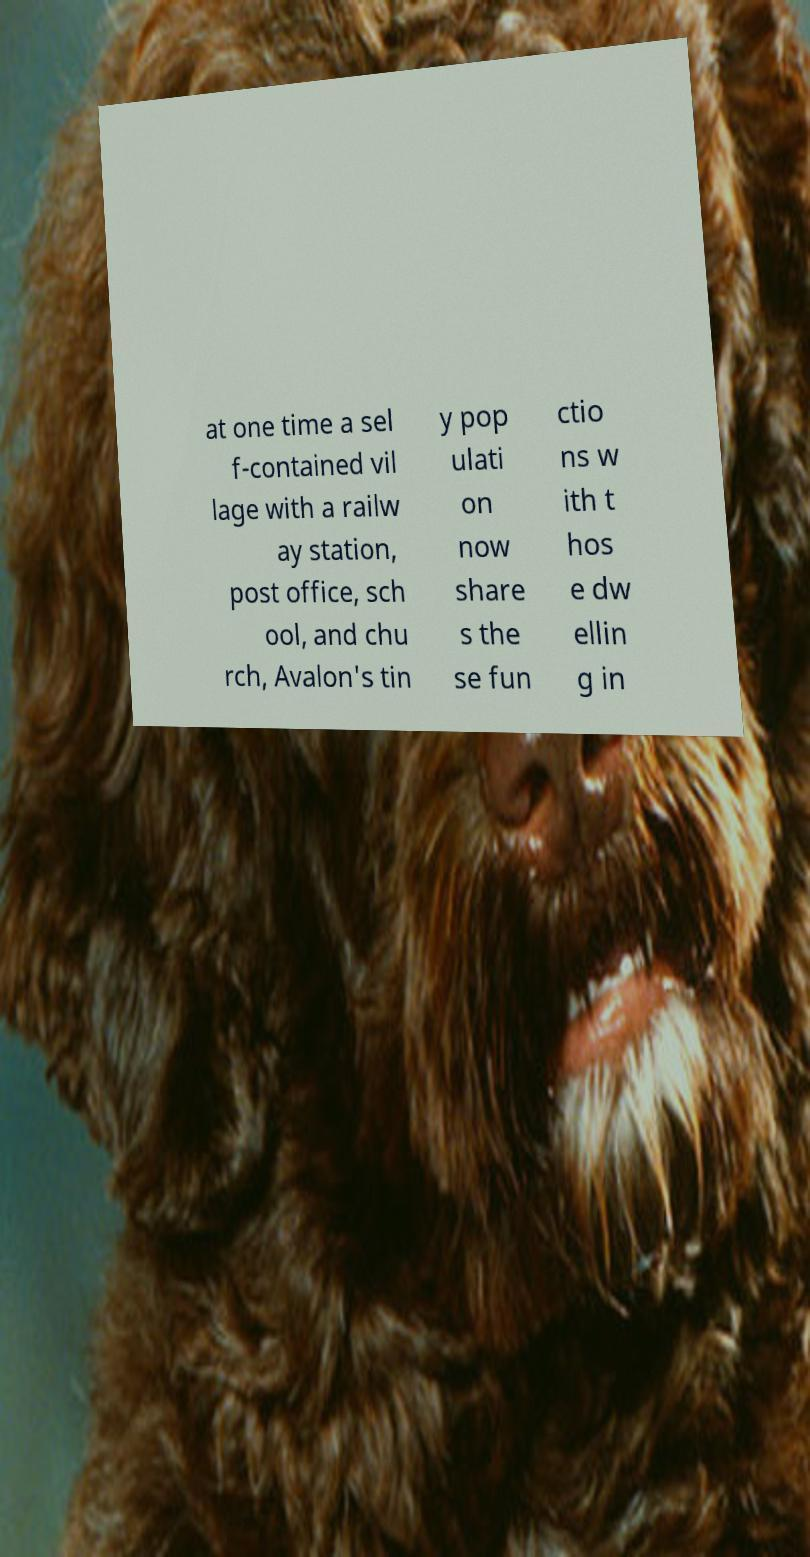Can you read and provide the text displayed in the image?This photo seems to have some interesting text. Can you extract and type it out for me? at one time a sel f-contained vil lage with a railw ay station, post office, sch ool, and chu rch, Avalon's tin y pop ulati on now share s the se fun ctio ns w ith t hos e dw ellin g in 